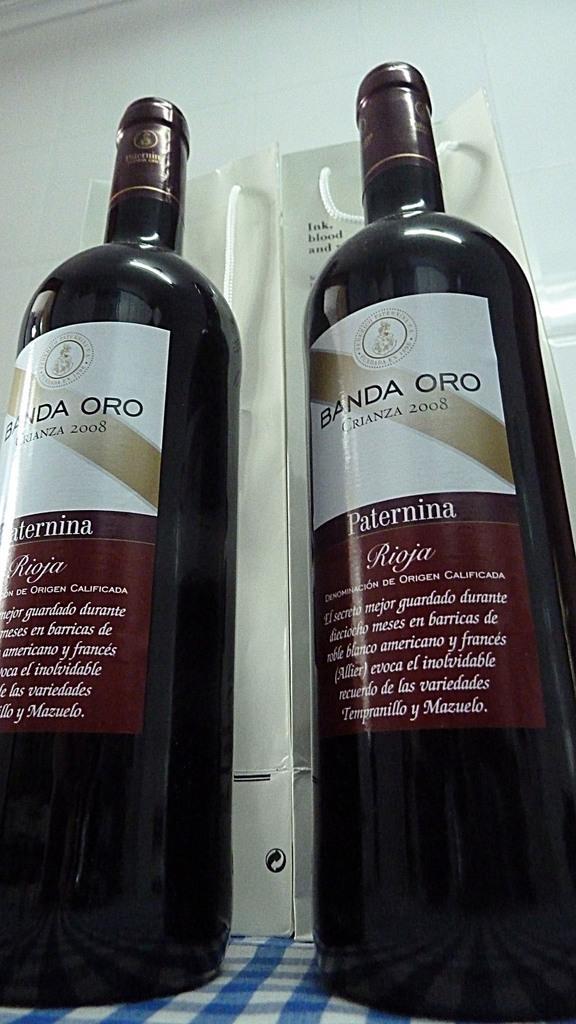In one or two sentences, can you explain what this image depicts? In this picture we can see two bottles on a cloth. There are some text and stickers on these bottles. We can see whiteboards in the background. 